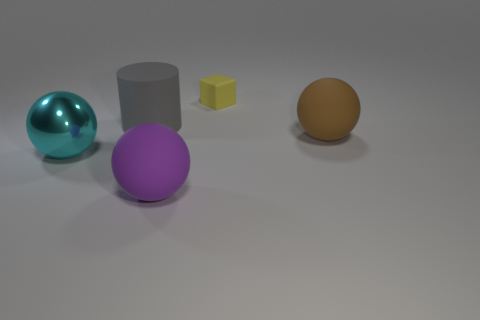Regarding the positions, could you infer any particular pattern or arrangement of the objects? The objects are arranged in a manner that does not suggest a deliberate pattern with the perspective of the image taken into account. They appear to be placed apart from each other without symmetric order or alignment. The sizes of the objects vary, and their placement seems random, potentially hinting at an informal or natural scene without human arrangement, or it might be intended to highlight the individual properties of each object by isolating them within the space. 